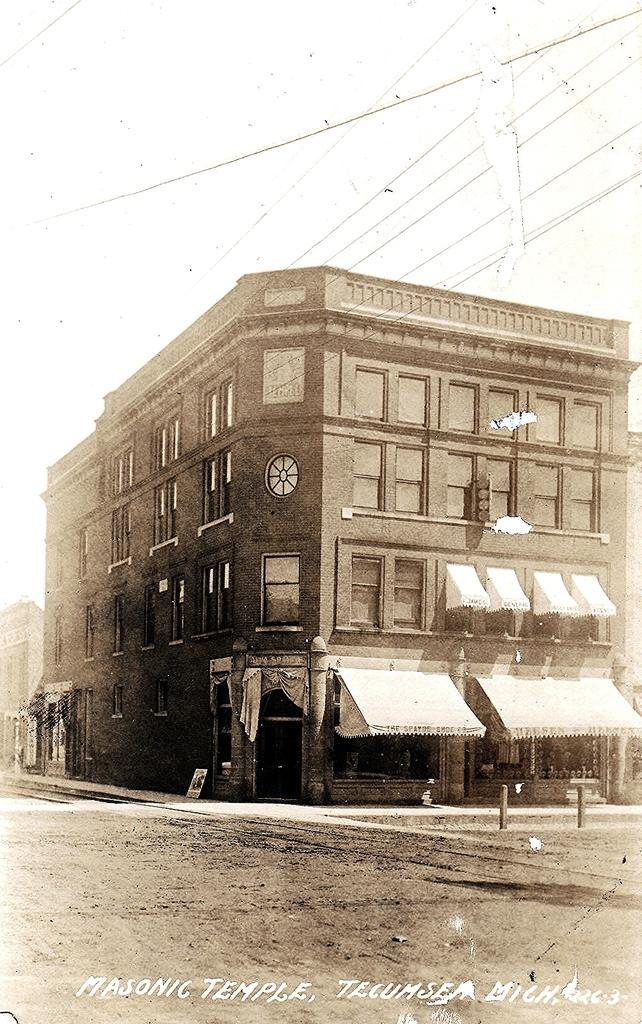What is the color scheme of the image? The image is black and white. What can be seen in the foreground of the image? There is a road in the image. What is visible in the background of the image? There is a building in the background of the image. What feature of the building is mentioned in the facts? The building has windows. What information is provided at the bottom of the image? There is text at the bottom of the image. Where is the school located in the image? There is no school present in the image. Can you describe the sofa in the image? There is no sofa present in the image. 